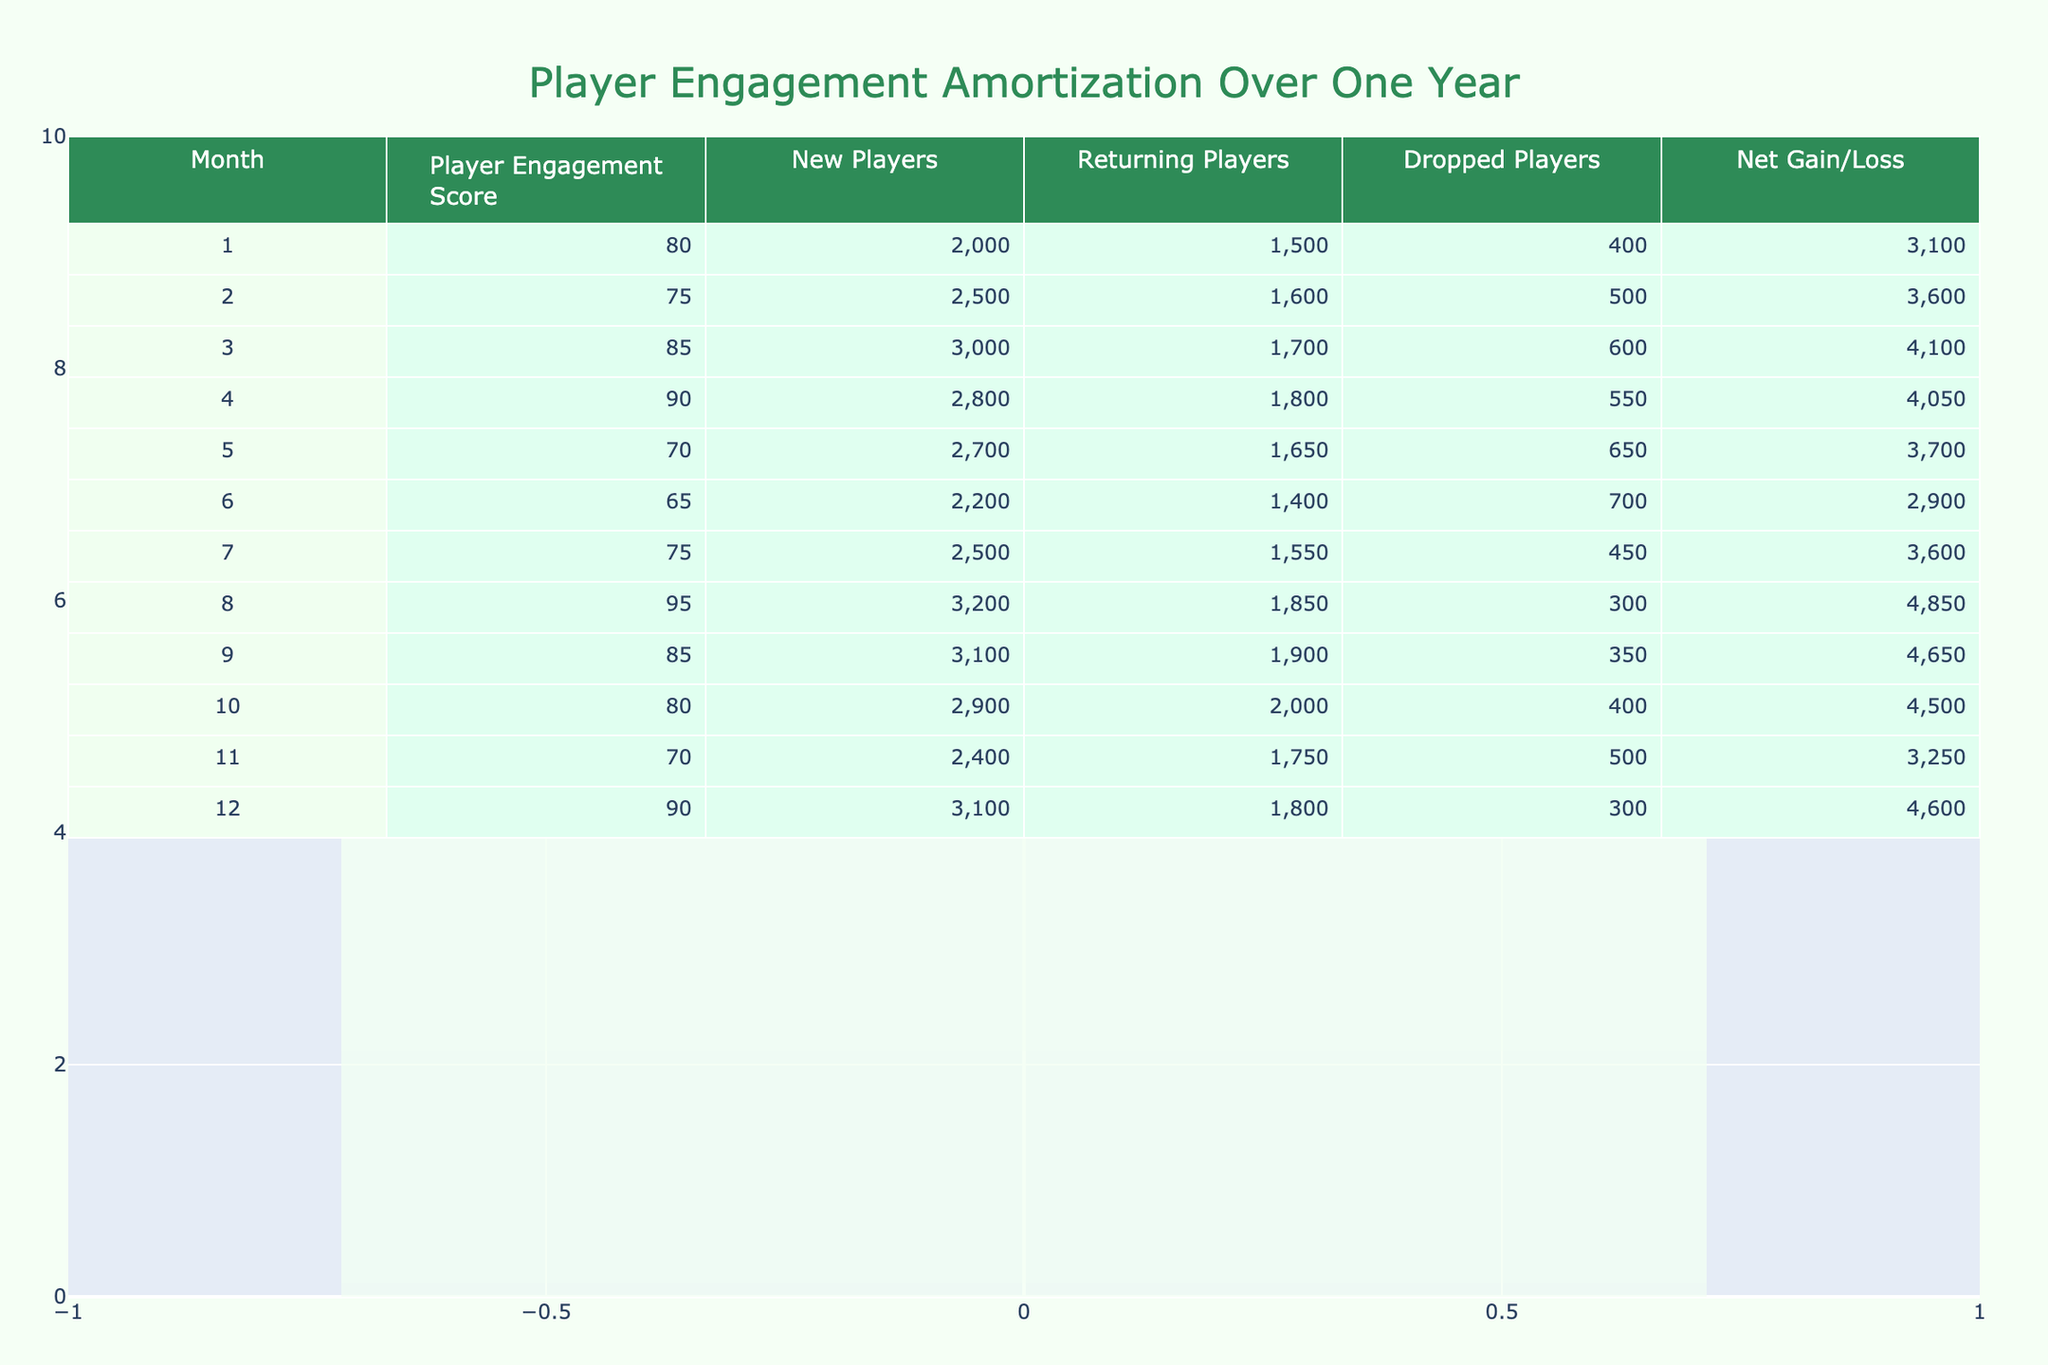What is the Player Engagement Score in Month 3? The Player Engagement Score for Month 3 is listed in the table under the corresponding month. According to the data, the score for Month 3 is 85.
Answer: 85 What was the highest Player Engagement Score recorded over the year? To find the highest Player Engagement Score, I can review all the scores in the table. Comparing each month's score, the highest value is 95, recorded in Month 8.
Answer: 95 How many Returning Players were there in Month 6? The number of Returning Players in Month 6 is specified directly in the table. In Month 6, the number of Returning Players is 1400.
Answer: 1400 What is the Net Gain/Loss for Month 10 compared to Month 4? The Net Gain/Loss for Month 10 is 4500, and for Month 4, it is 4050. To compare, I need to find the difference: 4500 - 4050 = 450.
Answer: 450 Did the number of New Players in Month 1 exceed 2000? The table shows that in Month 1, the number of New Players is exactly 2000. Since the question asks if it exceeded, the answer is no.
Answer: No What is the average Player Engagement Score over the 12 months? To find the average, I sum each Player Engagement Score from each month: 80 + 75 + 85 + 90 + 70 + 65 + 75 + 95 + 85 + 80 + 70 + 90 = 1005. Then I divide by the number of months, which is 12: 1005 / 12 = 83.75.
Answer: 83.75 In which month did the largest Net Gain/Loss occur? By examining the Net Gain/Loss values for each month, I see that Month 8 has the largest Net Gain/Loss of 4850. Thus, it is the month with the largest increase.
Answer: Month 8 What is the total number of Dropped Players over the entire year? To find the total number of Dropped Players, I can sum the values from each month: 400 + 500 + 600 + 550 + 650 + 700 + 450 + 300 + 350 + 500 + 300 = 5050.
Answer: 5050 Was there an increase in Returning Players from Month 3 to Month 12? In Month 3, Returning Players were 1700, and in Month 12, they were 1800. To determine if there was an increase, I subtract: 1800 - 1700 = 100, which indicates there was an increase.
Answer: Yes 